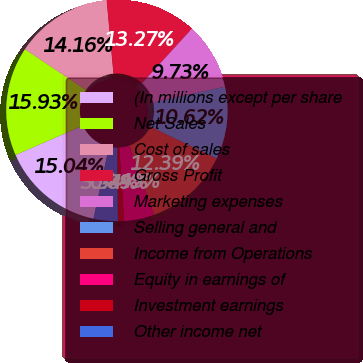Convert chart to OTSL. <chart><loc_0><loc_0><loc_500><loc_500><pie_chart><fcel>(In millions except per share<fcel>Net Sales<fcel>Cost of sales<fcel>Gross Profit<fcel>Marketing expenses<fcel>Selling general and<fcel>Income from Operations<fcel>Equity in earnings of<fcel>Investment earnings<fcel>Other income net<nl><fcel>15.04%<fcel>15.93%<fcel>14.16%<fcel>13.27%<fcel>9.73%<fcel>10.62%<fcel>12.39%<fcel>4.43%<fcel>0.89%<fcel>3.54%<nl></chart> 